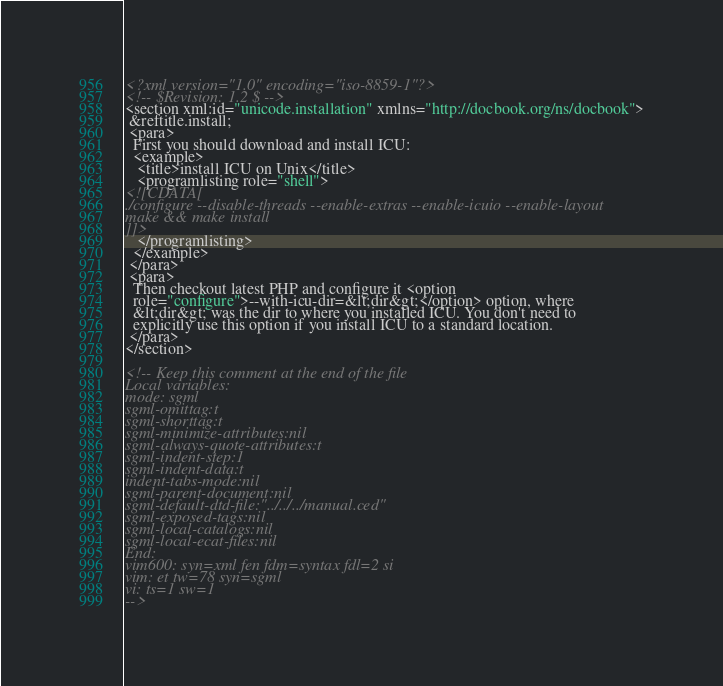<code> <loc_0><loc_0><loc_500><loc_500><_XML_><?xml version="1.0" encoding="iso-8859-1"?>
<!-- $Revision: 1.2 $ -->
<section xml:id="unicode.installation" xmlns="http://docbook.org/ns/docbook">
 &reftitle.install;
 <para>
  First you should download and install ICU:
  <example>
   <title>install ICU on Unix</title>
   <programlisting role="shell">
<![CDATA[
./configure --disable-threads --enable-extras --enable-icuio --enable-layout
make && make install
]]>
   </programlisting>
  </example>
 </para>
 <para>
  Then checkout latest PHP and configure it <option
  role="configure">--with-icu-dir=&lt;dir&gt;</option> option, where
  &lt;dir&gt; was the dir to where you installed ICU. You don't need to
  explicitly use this option if you install ICU to a standard location.
 </para>
</section>

<!-- Keep this comment at the end of the file
Local variables:
mode: sgml
sgml-omittag:t
sgml-shorttag:t
sgml-minimize-attributes:nil
sgml-always-quote-attributes:t
sgml-indent-step:1
sgml-indent-data:t
indent-tabs-mode:nil
sgml-parent-document:nil
sgml-default-dtd-file:"../../../manual.ced"
sgml-exposed-tags:nil
sgml-local-catalogs:nil
sgml-local-ecat-files:nil
End:
vim600: syn=xml fen fdm=syntax fdl=2 si
vim: et tw=78 syn=sgml
vi: ts=1 sw=1
-->
</code> 